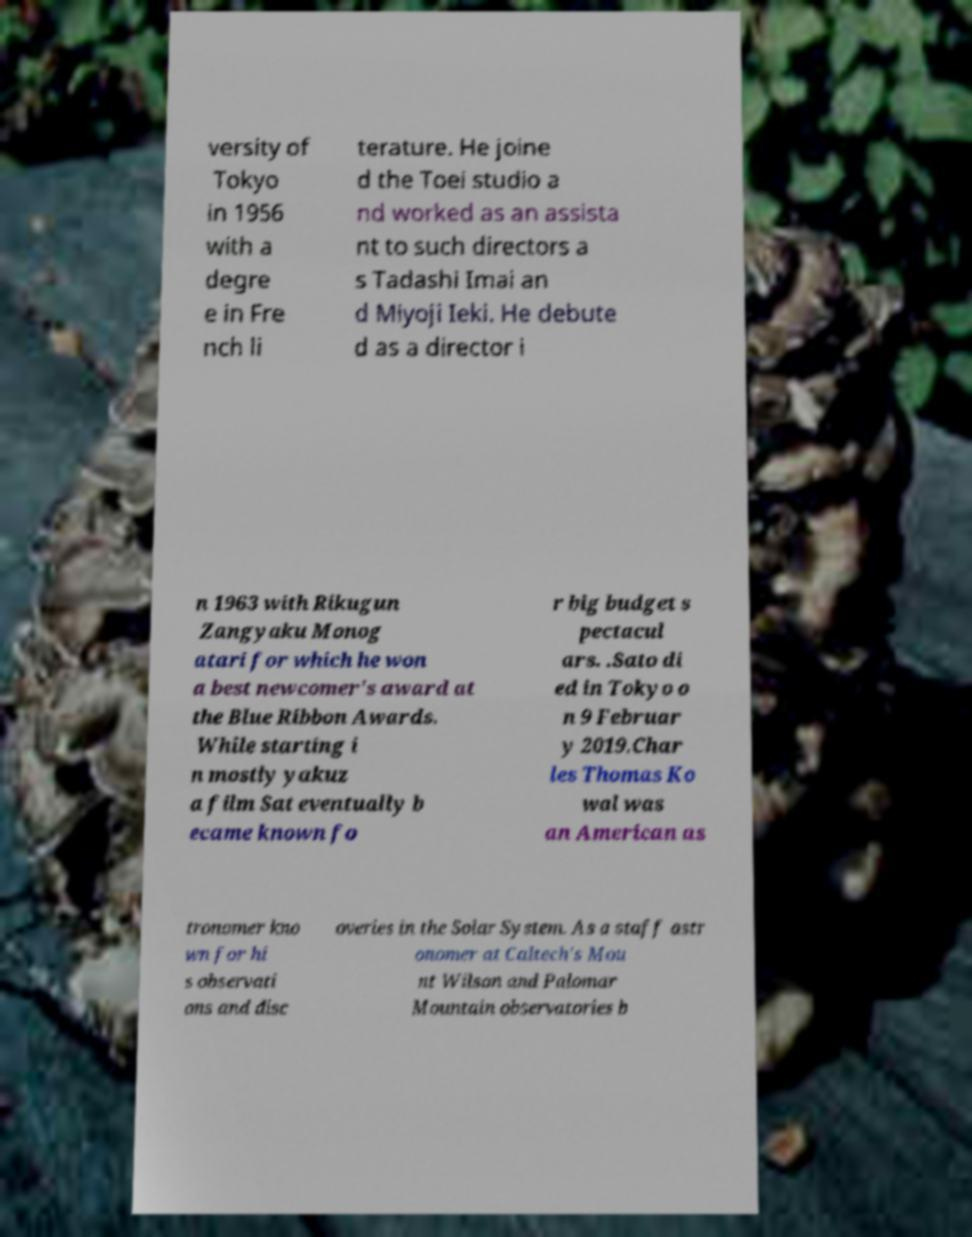Please read and relay the text visible in this image. What does it say? versity of Tokyo in 1956 with a degre e in Fre nch li terature. He joine d the Toei studio a nd worked as an assista nt to such directors a s Tadashi Imai an d Miyoji Ieki. He debute d as a director i n 1963 with Rikugun Zangyaku Monog atari for which he won a best newcomer's award at the Blue Ribbon Awards. While starting i n mostly yakuz a film Sat eventually b ecame known fo r big budget s pectacul ars. .Sato di ed in Tokyo o n 9 Februar y 2019.Char les Thomas Ko wal was an American as tronomer kno wn for hi s observati ons and disc overies in the Solar System. As a staff astr onomer at Caltech's Mou nt Wilson and Palomar Mountain observatories b 